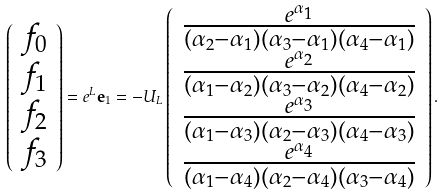<formula> <loc_0><loc_0><loc_500><loc_500>\left ( \begin{array} { c } f _ { 0 } \\ f _ { 1 } \\ f _ { 2 } \\ f _ { 3 } \end{array} \right ) = e ^ { L } { \mathbf e } _ { 1 } = - U _ { L } \left ( \begin{array} { c } \frac { e ^ { \alpha _ { 1 } } } { ( \alpha _ { 2 } - \alpha _ { 1 } ) ( \alpha _ { 3 } - \alpha _ { 1 } ) ( \alpha _ { 4 } - \alpha _ { 1 } ) } \\ \frac { e ^ { \alpha _ { 2 } } } { ( \alpha _ { 1 } - \alpha _ { 2 } ) ( \alpha _ { 3 } - \alpha _ { 2 } ) ( \alpha _ { 4 } - \alpha _ { 2 } ) } \\ \frac { e ^ { \alpha _ { 3 } } } { ( \alpha _ { 1 } - \alpha _ { 3 } ) ( \alpha _ { 2 } - \alpha _ { 3 } ) ( \alpha _ { 4 } - \alpha _ { 3 } ) } \\ \frac { e ^ { \alpha _ { 4 } } } { ( \alpha _ { 1 } - \alpha _ { 4 } ) ( \alpha _ { 2 } - \alpha _ { 4 } ) ( \alpha _ { 3 } - \alpha _ { 4 } ) } \end{array} \right ) .</formula> 